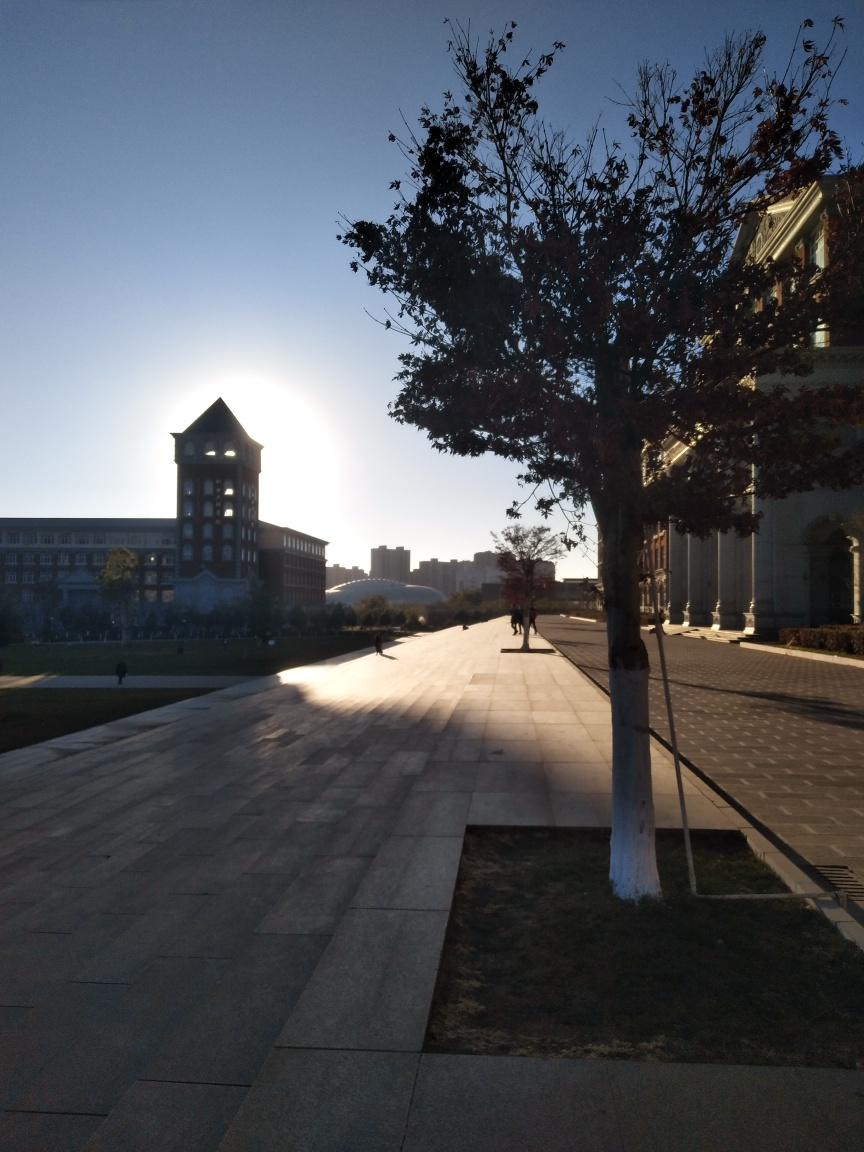Is the quality of this image relatively good? The image is of decent quality, showing a clear scene with good composition, but there's a slight underexposure due to the backlighting from the sun near the horizon which may affect the visibility of finer details. 